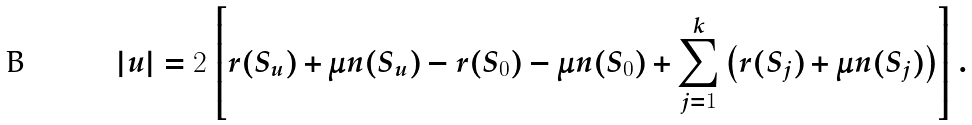Convert formula to latex. <formula><loc_0><loc_0><loc_500><loc_500>| u | = 2 \left [ r ( S _ { u } ) + \mu n ( S _ { u } ) - r ( S _ { 0 } ) - \mu n ( S _ { 0 } ) + \sum _ { j = 1 } ^ { k } \left ( r ( S _ { j } ) + \mu n ( S _ { j } ) \right ) \right ] .</formula> 